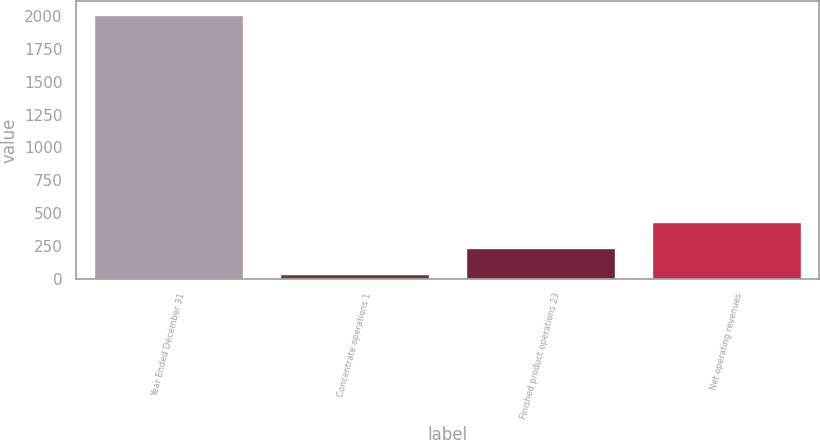Convert chart to OTSL. <chart><loc_0><loc_0><loc_500><loc_500><bar_chart><fcel>Year Ended December 31<fcel>Concentrate operations 1<fcel>Finished product operations 23<fcel>Net operating revenues<nl><fcel>2012<fcel>38<fcel>235.4<fcel>432.8<nl></chart> 